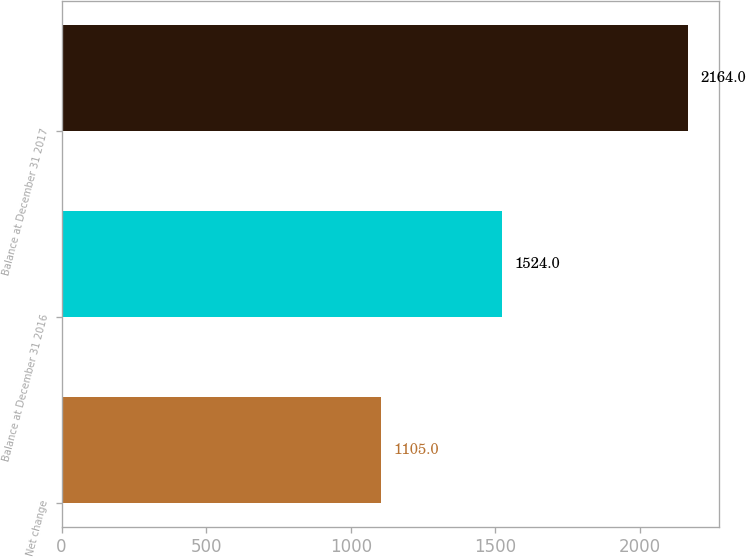<chart> <loc_0><loc_0><loc_500><loc_500><bar_chart><fcel>Net change<fcel>Balance at December 31 2016<fcel>Balance at December 31 2017<nl><fcel>1105<fcel>1524<fcel>2164<nl></chart> 